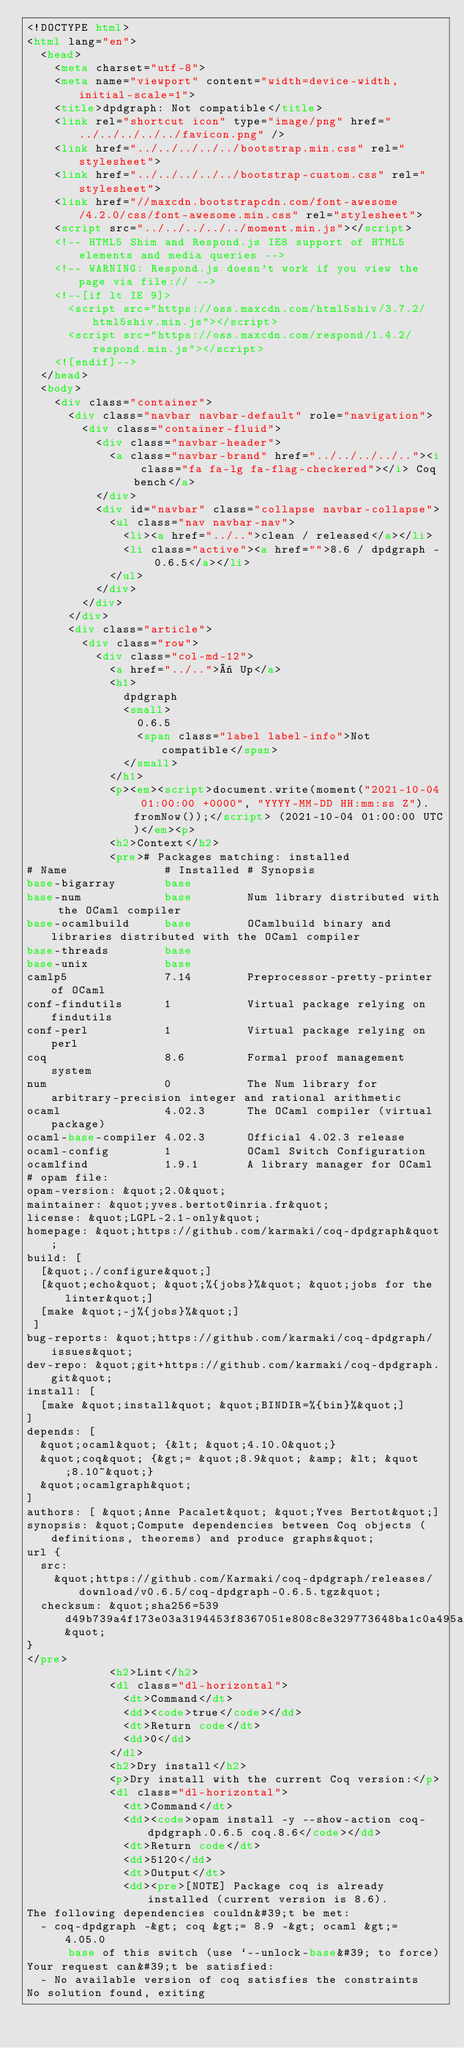Convert code to text. <code><loc_0><loc_0><loc_500><loc_500><_HTML_><!DOCTYPE html>
<html lang="en">
  <head>
    <meta charset="utf-8">
    <meta name="viewport" content="width=device-width, initial-scale=1">
    <title>dpdgraph: Not compatible</title>
    <link rel="shortcut icon" type="image/png" href="../../../../../favicon.png" />
    <link href="../../../../../bootstrap.min.css" rel="stylesheet">
    <link href="../../../../../bootstrap-custom.css" rel="stylesheet">
    <link href="//maxcdn.bootstrapcdn.com/font-awesome/4.2.0/css/font-awesome.min.css" rel="stylesheet">
    <script src="../../../../../moment.min.js"></script>
    <!-- HTML5 Shim and Respond.js IE8 support of HTML5 elements and media queries -->
    <!-- WARNING: Respond.js doesn't work if you view the page via file:// -->
    <!--[if lt IE 9]>
      <script src="https://oss.maxcdn.com/html5shiv/3.7.2/html5shiv.min.js"></script>
      <script src="https://oss.maxcdn.com/respond/1.4.2/respond.min.js"></script>
    <![endif]-->
  </head>
  <body>
    <div class="container">
      <div class="navbar navbar-default" role="navigation">
        <div class="container-fluid">
          <div class="navbar-header">
            <a class="navbar-brand" href="../../../../.."><i class="fa fa-lg fa-flag-checkered"></i> Coq bench</a>
          </div>
          <div id="navbar" class="collapse navbar-collapse">
            <ul class="nav navbar-nav">
              <li><a href="../..">clean / released</a></li>
              <li class="active"><a href="">8.6 / dpdgraph - 0.6.5</a></li>
            </ul>
          </div>
        </div>
      </div>
      <div class="article">
        <div class="row">
          <div class="col-md-12">
            <a href="../..">« Up</a>
            <h1>
              dpdgraph
              <small>
                0.6.5
                <span class="label label-info">Not compatible</span>
              </small>
            </h1>
            <p><em><script>document.write(moment("2021-10-04 01:00:00 +0000", "YYYY-MM-DD HH:mm:ss Z").fromNow());</script> (2021-10-04 01:00:00 UTC)</em><p>
            <h2>Context</h2>
            <pre># Packages matching: installed
# Name              # Installed # Synopsis
base-bigarray       base
base-num            base        Num library distributed with the OCaml compiler
base-ocamlbuild     base        OCamlbuild binary and libraries distributed with the OCaml compiler
base-threads        base
base-unix           base
camlp5              7.14        Preprocessor-pretty-printer of OCaml
conf-findutils      1           Virtual package relying on findutils
conf-perl           1           Virtual package relying on perl
coq                 8.6         Formal proof management system
num                 0           The Num library for arbitrary-precision integer and rational arithmetic
ocaml               4.02.3      The OCaml compiler (virtual package)
ocaml-base-compiler 4.02.3      Official 4.02.3 release
ocaml-config        1           OCaml Switch Configuration
ocamlfind           1.9.1       A library manager for OCaml
# opam file:
opam-version: &quot;2.0&quot;
maintainer: &quot;yves.bertot@inria.fr&quot;
license: &quot;LGPL-2.1-only&quot;
homepage: &quot;https://github.com/karmaki/coq-dpdgraph&quot;
build: [
  [&quot;./configure&quot;]
  [&quot;echo&quot; &quot;%{jobs}%&quot; &quot;jobs for the linter&quot;]
  [make &quot;-j%{jobs}%&quot;]
 ]
bug-reports: &quot;https://github.com/karmaki/coq-dpdgraph/issues&quot;
dev-repo: &quot;git+https://github.com/karmaki/coq-dpdgraph.git&quot;
install: [
  [make &quot;install&quot; &quot;BINDIR=%{bin}%&quot;]
]
depends: [
  &quot;ocaml&quot; {&lt; &quot;4.10.0&quot;}
  &quot;coq&quot; {&gt;= &quot;8.9&quot; &amp; &lt; &quot;8.10~&quot;}
  &quot;ocamlgraph&quot;
]
authors: [ &quot;Anne Pacalet&quot; &quot;Yves Bertot&quot;]
synopsis: &quot;Compute dependencies between Coq objects (definitions, theorems) and produce graphs&quot;
url {
  src:
    &quot;https://github.com/Karmaki/coq-dpdgraph/releases/download/v0.6.5/coq-dpdgraph-0.6.5.tgz&quot;
  checksum: &quot;sha256=539d49b739a4f173e03a3194453f8367051e808c8e329773648ba1c0a495a07f&quot;
}
</pre>
            <h2>Lint</h2>
            <dl class="dl-horizontal">
              <dt>Command</dt>
              <dd><code>true</code></dd>
              <dt>Return code</dt>
              <dd>0</dd>
            </dl>
            <h2>Dry install</h2>
            <p>Dry install with the current Coq version:</p>
            <dl class="dl-horizontal">
              <dt>Command</dt>
              <dd><code>opam install -y --show-action coq-dpdgraph.0.6.5 coq.8.6</code></dd>
              <dt>Return code</dt>
              <dd>5120</dd>
              <dt>Output</dt>
              <dd><pre>[NOTE] Package coq is already installed (current version is 8.6).
The following dependencies couldn&#39;t be met:
  - coq-dpdgraph -&gt; coq &gt;= 8.9 -&gt; ocaml &gt;= 4.05.0
      base of this switch (use `--unlock-base&#39; to force)
Your request can&#39;t be satisfied:
  - No available version of coq satisfies the constraints
No solution found, exiting</code> 